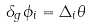Convert formula to latex. <formula><loc_0><loc_0><loc_500><loc_500>\delta _ { g } \phi _ { i } = \Delta _ { i } \theta</formula> 